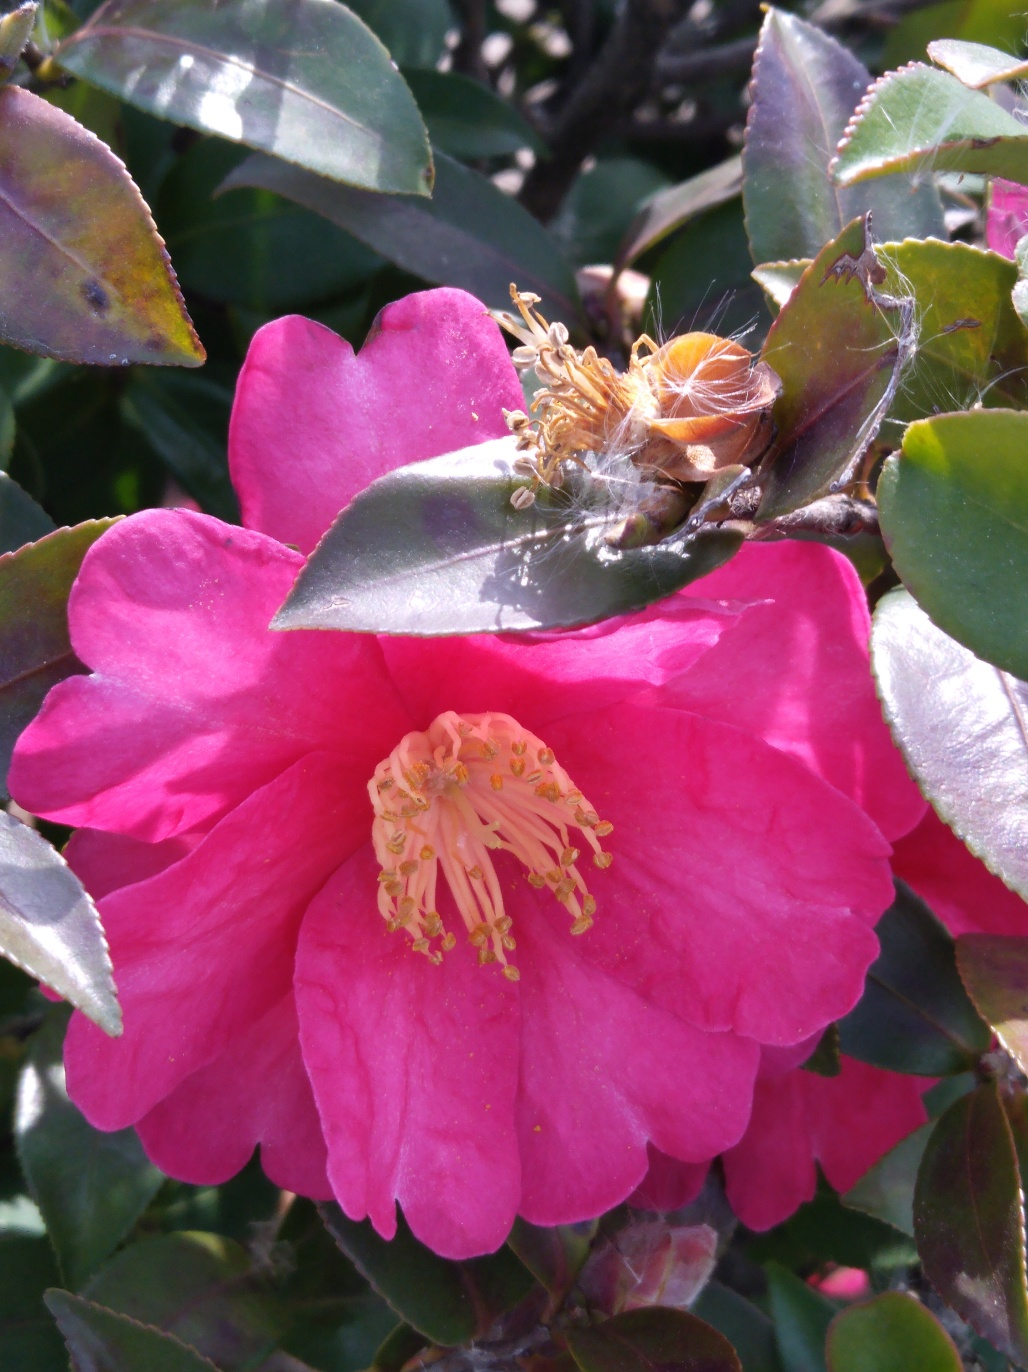Can you describe how the spider webs affect the appearance of the flower? Certainly. The spider webs drape delicately over the flower's petals and stamen, adding a layer of complexity to the flower's appearance. It creates a juxtaposition of natural beauty and the reality of the plant's ecosystem. 